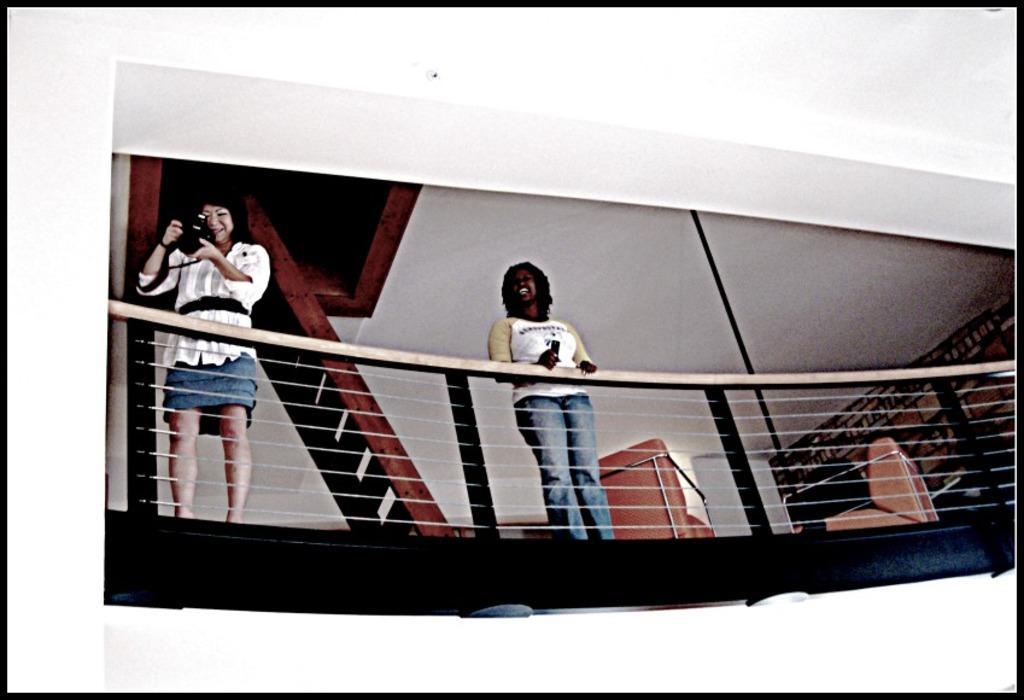How would you summarize this image in a sentence or two? In the center of the image we can see two people standing on the building and we can see a railing. In the background there is a shelf and a wall. 